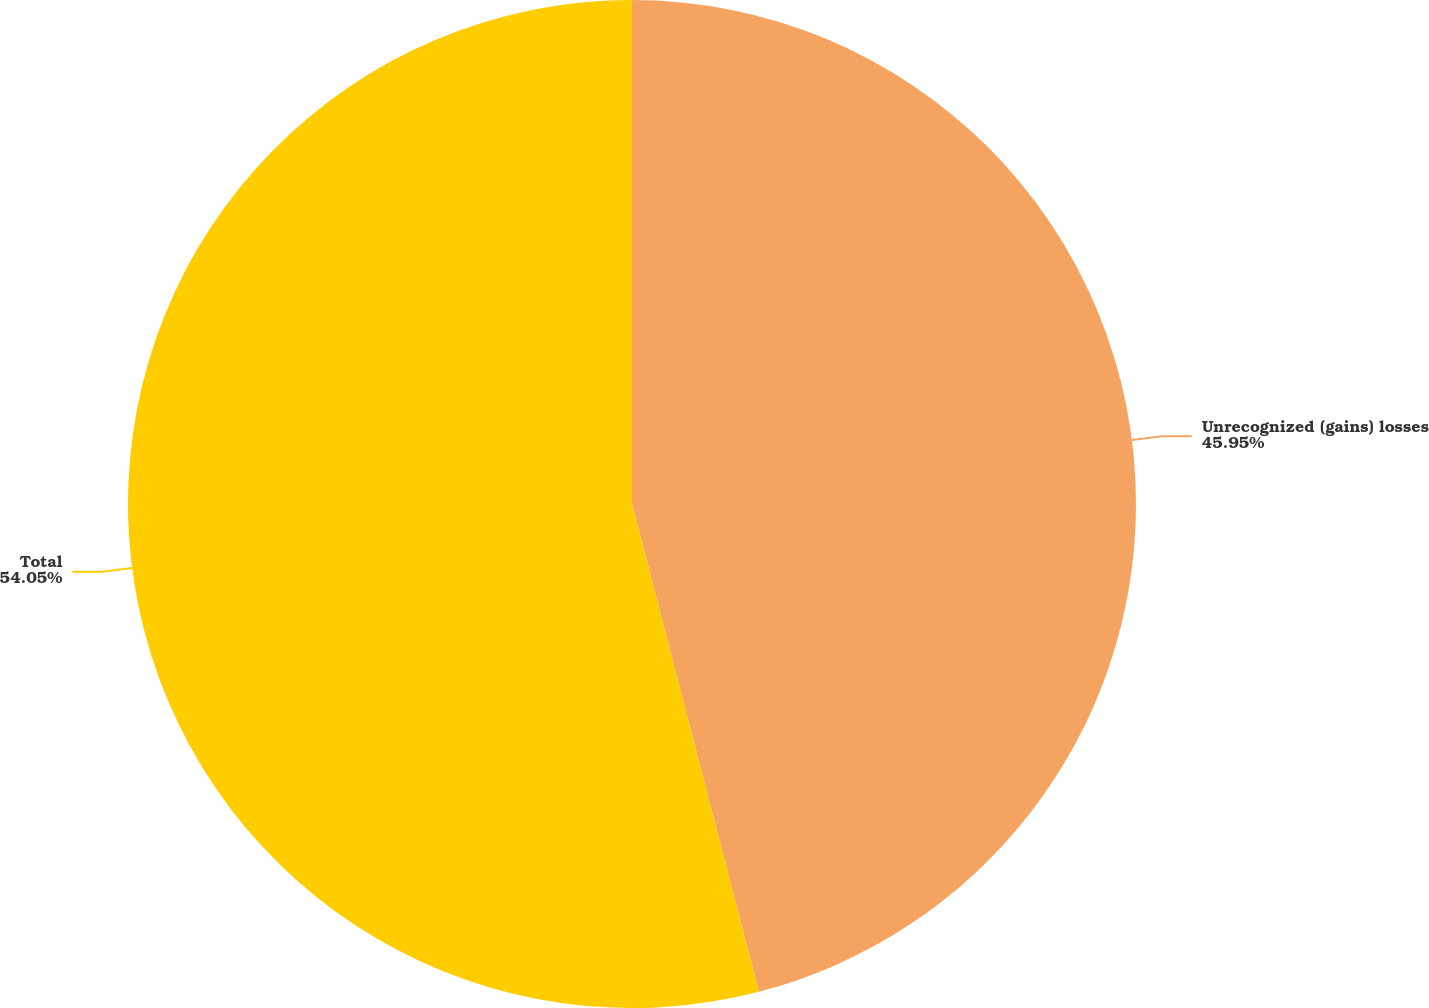Convert chart to OTSL. <chart><loc_0><loc_0><loc_500><loc_500><pie_chart><fcel>Unrecognized (gains) losses<fcel>Total<nl><fcel>45.95%<fcel>54.05%<nl></chart> 